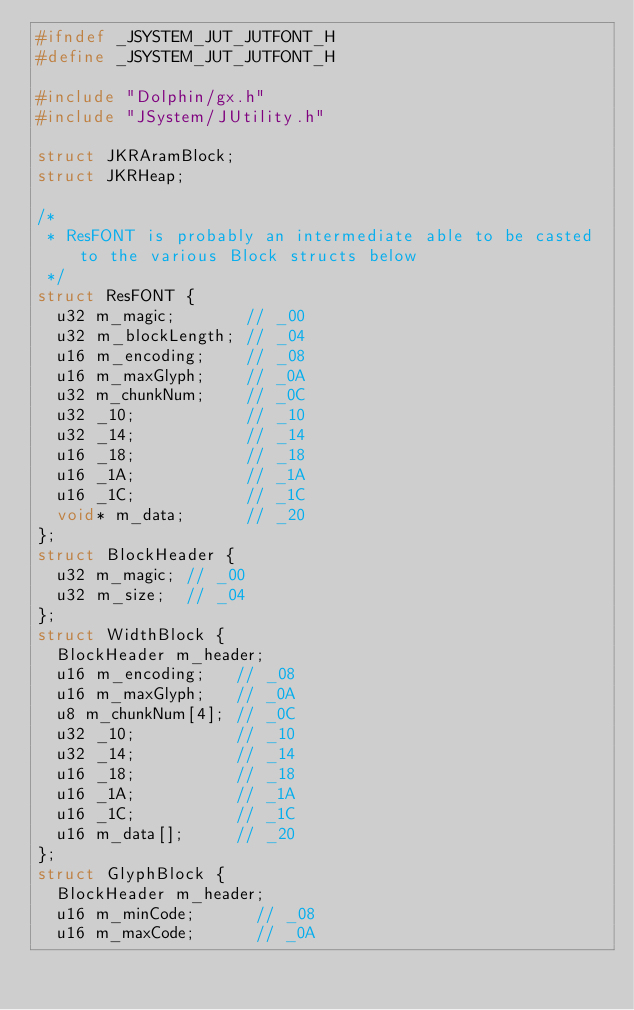<code> <loc_0><loc_0><loc_500><loc_500><_C_>#ifndef _JSYSTEM_JUT_JUTFONT_H
#define _JSYSTEM_JUT_JUTFONT_H

#include "Dolphin/gx.h"
#include "JSystem/JUtility.h"

struct JKRAramBlock;
struct JKRHeap;

/*
 * ResFONT is probably an intermediate able to be casted to the various Block structs below
 */
struct ResFONT {
	u32 m_magic;       // _00
	u32 m_blockLength; // _04
	u16 m_encoding;    // _08
	u16 m_maxGlyph;    // _0A
	u32 m_chunkNum;    // _0C
	u32 _10;           // _10
	u32 _14;           // _14
	u16 _18;           // _18
	u16 _1A;           // _1A
	u16 _1C;           // _1C
	void* m_data;      // _20
};
struct BlockHeader {
	u32 m_magic; // _00
	u32 m_size;  // _04
};
struct WidthBlock {
	BlockHeader m_header;
	u16 m_encoding;   // _08
	u16 m_maxGlyph;   // _0A
	u8 m_chunkNum[4]; // _0C
	u32 _10;          // _10
	u32 _14;          // _14
	u16 _18;          // _18
	u16 _1A;          // _1A
	u16 _1C;          // _1C
	u16 m_data[];     // _20
};
struct GlyphBlock {
	BlockHeader m_header;
	u16 m_minCode;      // _08
	u16 m_maxCode;      // _0A</code> 